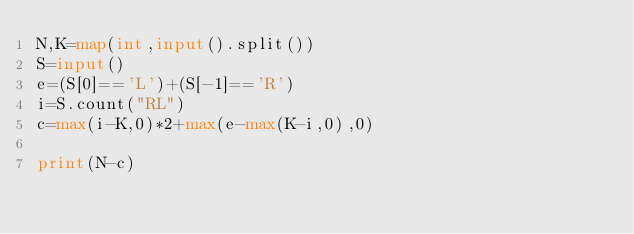Convert code to text. <code><loc_0><loc_0><loc_500><loc_500><_Python_>N,K=map(int,input().split())
S=input()
e=(S[0]=='L')+(S[-1]=='R')
i=S.count("RL")
c=max(i-K,0)*2+max(e-max(K-i,0),0)

print(N-c)</code> 